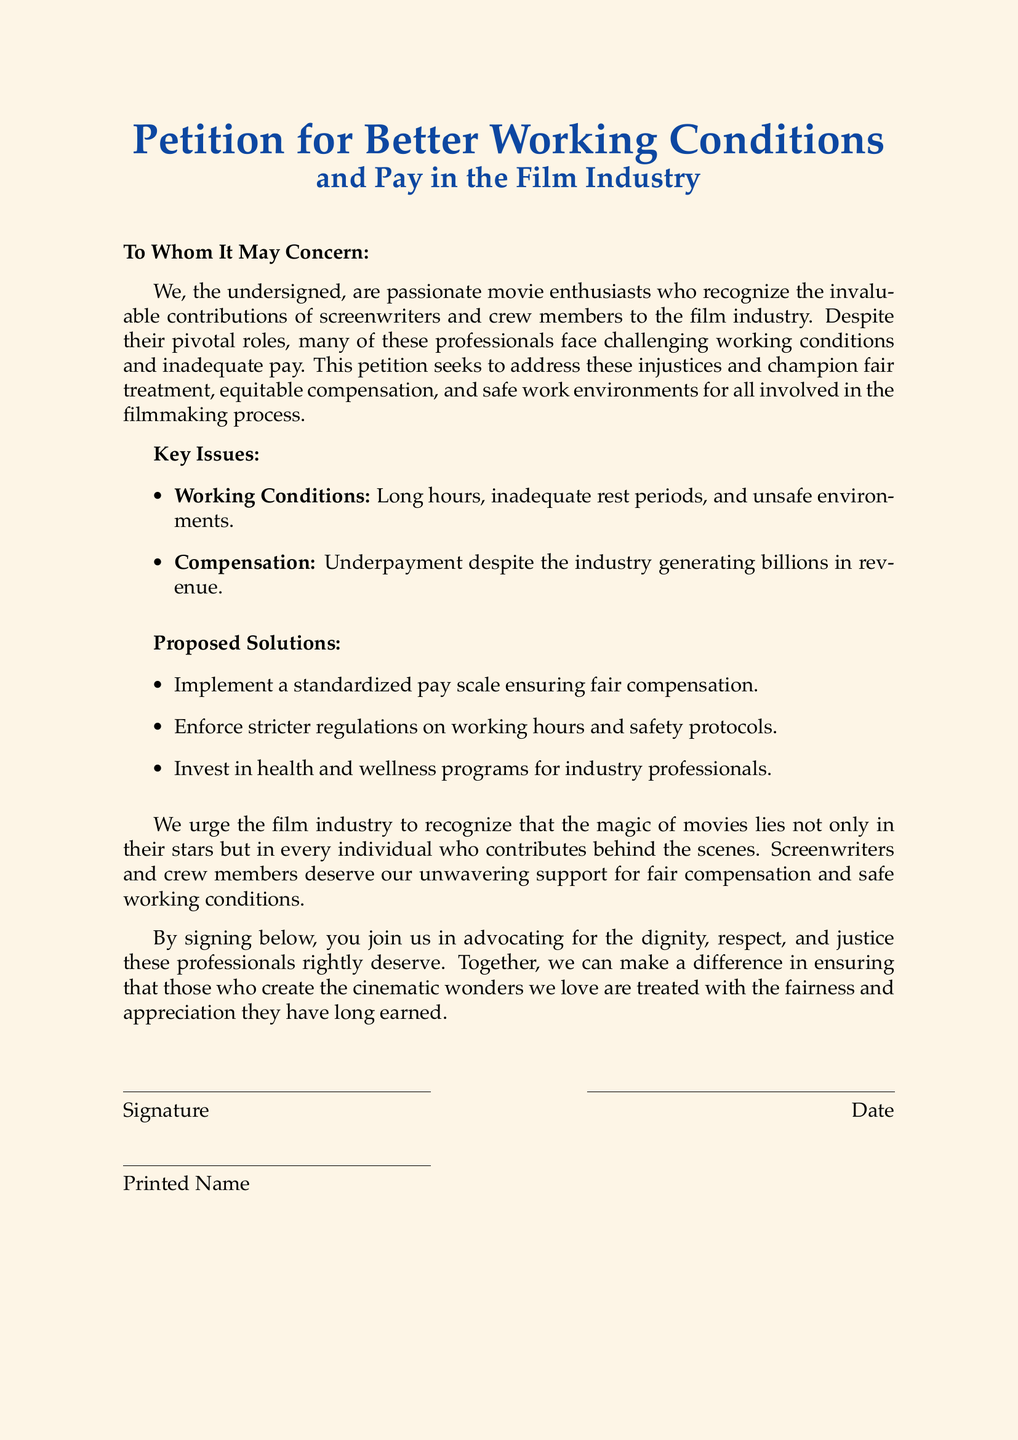What is the title of the petition? The title appears prominently at the top of the document, stating the purpose of the petition.
Answer: Petition for Better Working Conditions and Pay in the Film Industry What are the key issues mentioned in the petition? The petition lists the key issues affecting screenwriters and crew members, focusing on working conditions and pay.
Answer: Working Conditions and Compensation What is one proposed solution mentioned in the document? The document outlines proposed solutions to improve working conditions and pay for industry professionals.
Answer: Implement a standardized pay scale How many signatures are required for the petition? The document does not specify a number of signatures needed for the petition.
Answer: Not specified Who does the petition address? The opening line of the document clarifies who the petition is directed towards.
Answer: To Whom It May Concern What color is used for the title text? The document specifies the color used in the title format, reflecting its design choice.
Answer: Film blue What is stated about the film industry's revenue? A specific description in the document emphasizes the financial success of the industry juxtaposed with worker pay.
Answer: Generating billions in revenue What does the petition urge the film industry to recognize? The document makes a statement about the contributions of all individuals involved in filmmaking, not just stars.
Answer: The magic of movies lies not only in their stars What is included in the signature section? The signature section of the document has specific fields that need to be filled out by signers.
Answer: Signature, Date, Printed Name 